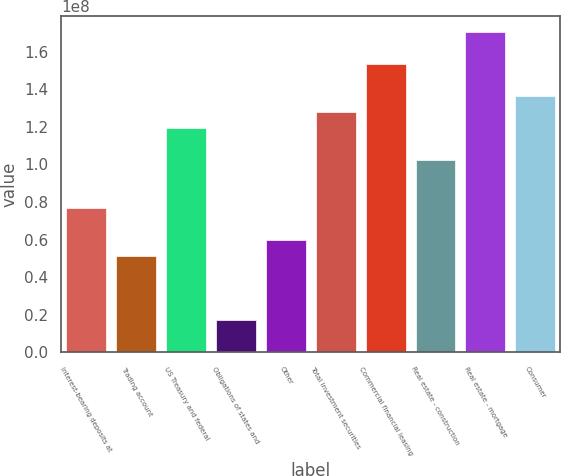Convert chart to OTSL. <chart><loc_0><loc_0><loc_500><loc_500><bar_chart><fcel>Interest-bearing deposits at<fcel>Trading account<fcel>US Treasury and federal<fcel>Obligations of states and<fcel>Other<fcel>Total investment securities<fcel>Commercial financial leasing<fcel>Real estate - construction<fcel>Real estate - mortgage<fcel>Consumer<nl><fcel>7.66528e+07<fcel>5.11242e+07<fcel>1.19201e+08<fcel>1.7086e+07<fcel>5.96337e+07<fcel>1.2771e+08<fcel>1.53239e+08<fcel>1.02181e+08<fcel>1.70258e+08<fcel>1.3622e+08<nl></chart> 